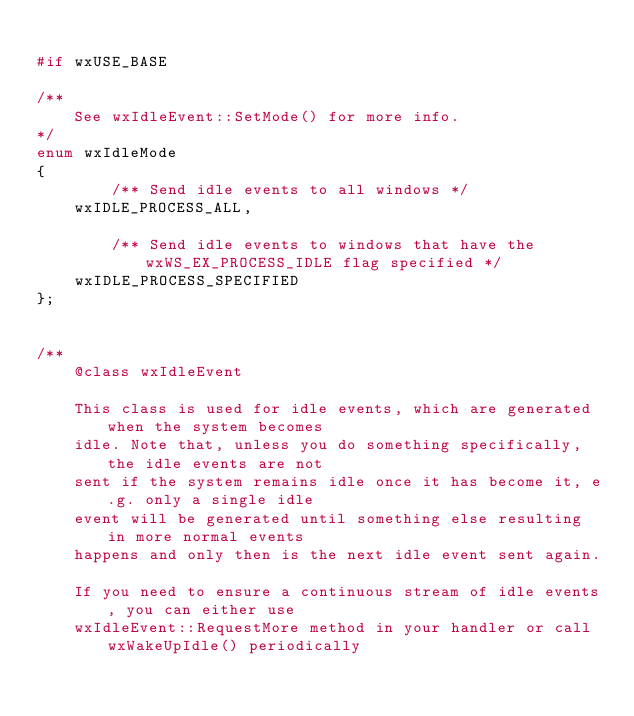<code> <loc_0><loc_0><loc_500><loc_500><_C_>
#if wxUSE_BASE

/**
    See wxIdleEvent::SetMode() for more info.
*/
enum wxIdleMode
{
        /** Send idle events to all windows */
    wxIDLE_PROCESS_ALL,

        /** Send idle events to windows that have the wxWS_EX_PROCESS_IDLE flag specified */
    wxIDLE_PROCESS_SPECIFIED
};


/**
    @class wxIdleEvent

    This class is used for idle events, which are generated when the system becomes
    idle. Note that, unless you do something specifically, the idle events are not
    sent if the system remains idle once it has become it, e.g. only a single idle
    event will be generated until something else resulting in more normal events
    happens and only then is the next idle event sent again.

    If you need to ensure a continuous stream of idle events, you can either use
    wxIdleEvent::RequestMore method in your handler or call wxWakeUpIdle() periodically</code> 